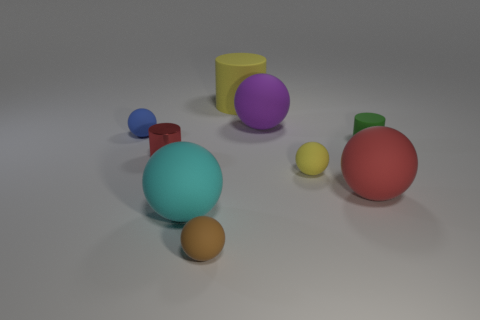Subtract all large red matte spheres. How many spheres are left? 5 Subtract all brown spheres. How many spheres are left? 5 Add 1 large blue blocks. How many objects exist? 10 Subtract all balls. How many objects are left? 3 Subtract all gray cylinders. Subtract all green cubes. How many cylinders are left? 3 Subtract all green matte things. Subtract all yellow spheres. How many objects are left? 7 Add 7 big yellow cylinders. How many big yellow cylinders are left? 8 Add 9 large red balls. How many large red balls exist? 10 Subtract 0 purple cylinders. How many objects are left? 9 